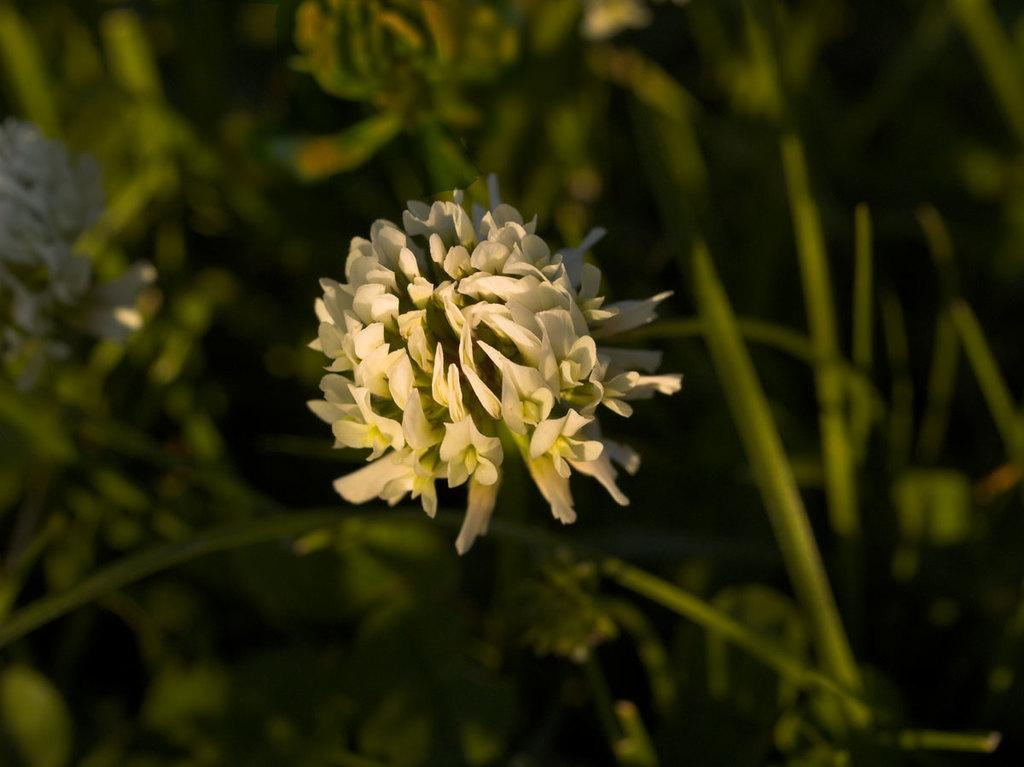What is the main subject in the middle of the image? There is a flower in the middle of the image. What other plant-related objects can be seen in the image? There are plants in the image. Can you describe the background of the image? The background of the image is blurred. What type of death can be seen in the image? There is no death present in the image; it features a flower and plants. Can you describe the cow in the image? There is no cow present in the image. What is the girl doing in the image? There is no girl present in the image. 